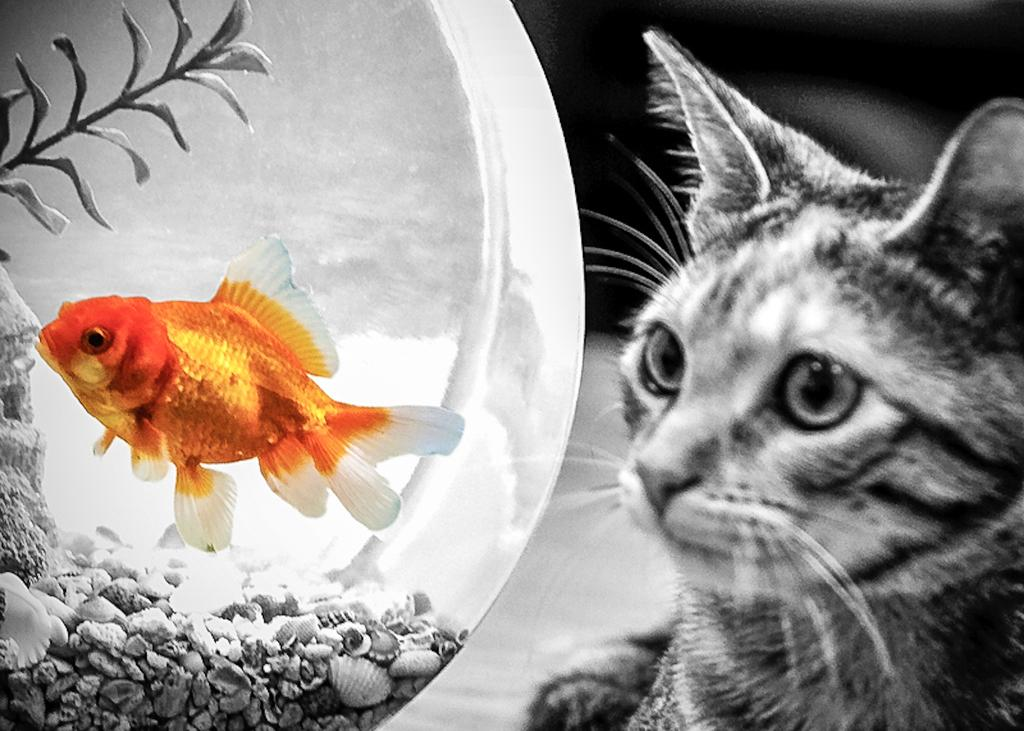What type of animal is in the image? There is a cat in the image. Where is the cat located in relation to the pot? The cat is beside the pot. What is inside the pot? There is a fish and rocks in the pot. What type of guide can be seen holding a note in the image? There is no guide or note present in the image; it features a cat beside a pot with a fish and rocks inside. 